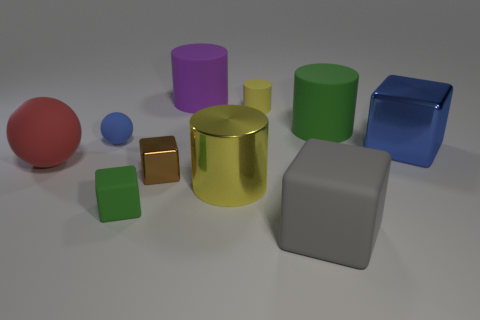What color is the big metallic thing that is the same shape as the tiny yellow thing?
Ensure brevity in your answer.  Yellow. What is the shape of the tiny blue rubber object?
Offer a terse response. Sphere. Are there more yellow metallic cylinders in front of the small green matte object than small things that are in front of the small shiny block?
Keep it short and to the point. No. What number of other objects are there of the same size as the blue metal block?
Provide a succinct answer. 5. What material is the cylinder that is to the left of the tiny rubber cylinder and behind the large green matte object?
Ensure brevity in your answer.  Rubber. There is a large blue thing that is the same shape as the small green thing; what is it made of?
Offer a very short reply. Metal. What number of large red balls are left of the metallic cube right of the green object that is on the right side of the big yellow cylinder?
Give a very brief answer. 1. Are there any other things of the same color as the tiny rubber ball?
Your response must be concise. Yes. How many objects are on the left side of the gray rubber thing and in front of the large yellow object?
Your answer should be very brief. 1. There is a yellow cylinder that is behind the large yellow object; is its size the same as the metallic block right of the yellow matte object?
Provide a succinct answer. No. 